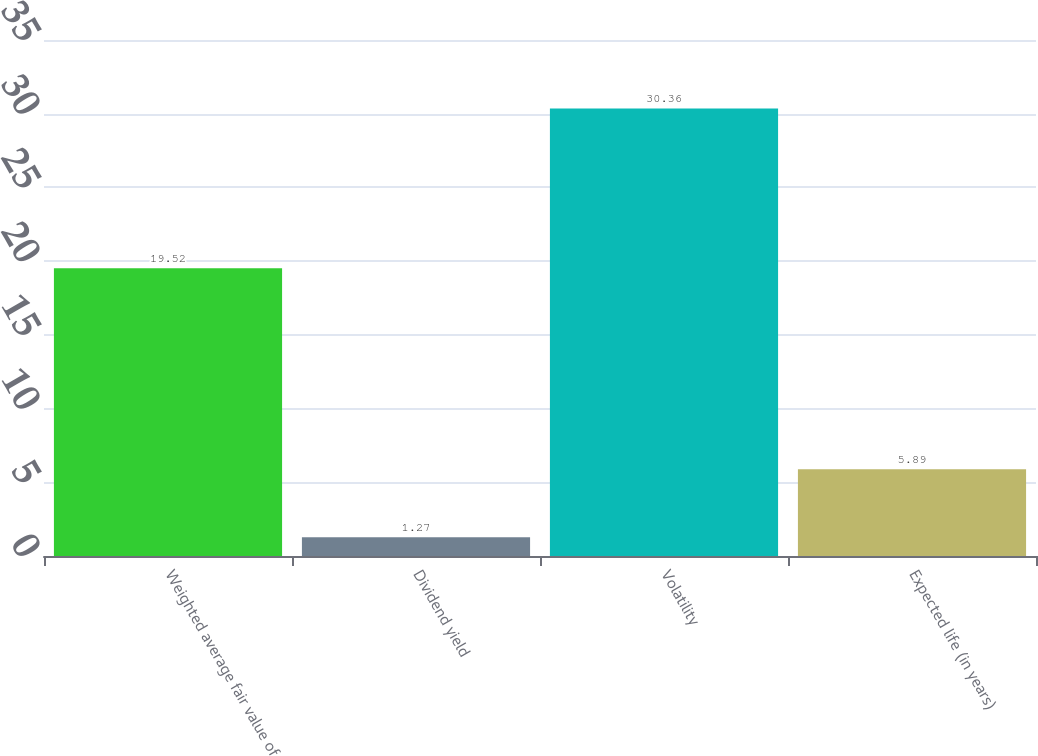Convert chart. <chart><loc_0><loc_0><loc_500><loc_500><bar_chart><fcel>Weighted average fair value of<fcel>Dividend yield<fcel>Volatility<fcel>Expected life (in years)<nl><fcel>19.52<fcel>1.27<fcel>30.36<fcel>5.89<nl></chart> 